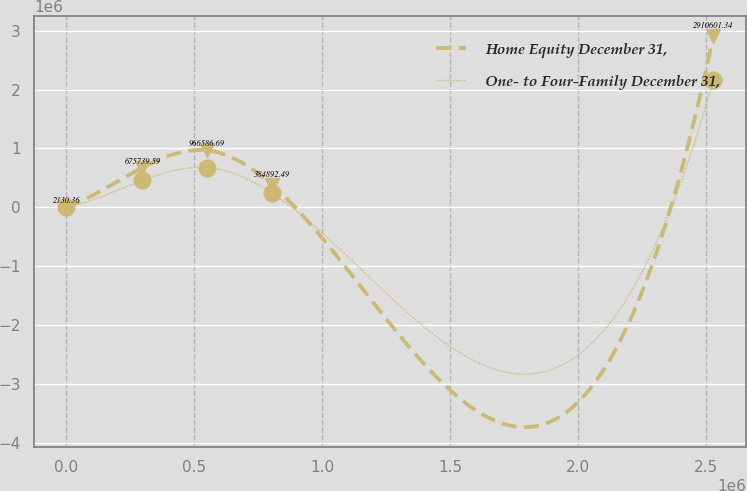Convert chart to OTSL. <chart><loc_0><loc_0><loc_500><loc_500><line_chart><ecel><fcel>Home Equity December 31,<fcel>One- to Four-Family December 31,<nl><fcel>2374.31<fcel>2130.36<fcel>1862.94<nl><fcel>299473<fcel>675740<fcel>458103<nl><fcel>551982<fcel>966587<fcel>674273<nl><fcel>804492<fcel>384892<fcel>241932<nl><fcel>2.52747e+06<fcel>2.9106e+06<fcel>2.16357e+06<nl></chart> 